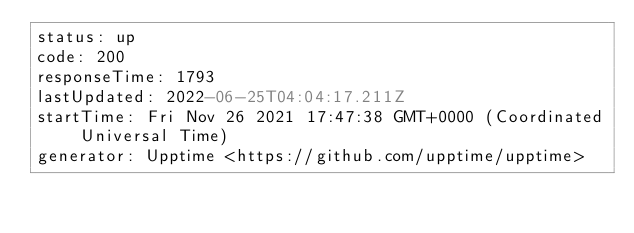<code> <loc_0><loc_0><loc_500><loc_500><_YAML_>status: up
code: 200
responseTime: 1793
lastUpdated: 2022-06-25T04:04:17.211Z
startTime: Fri Nov 26 2021 17:47:38 GMT+0000 (Coordinated Universal Time)
generator: Upptime <https://github.com/upptime/upptime>
</code> 